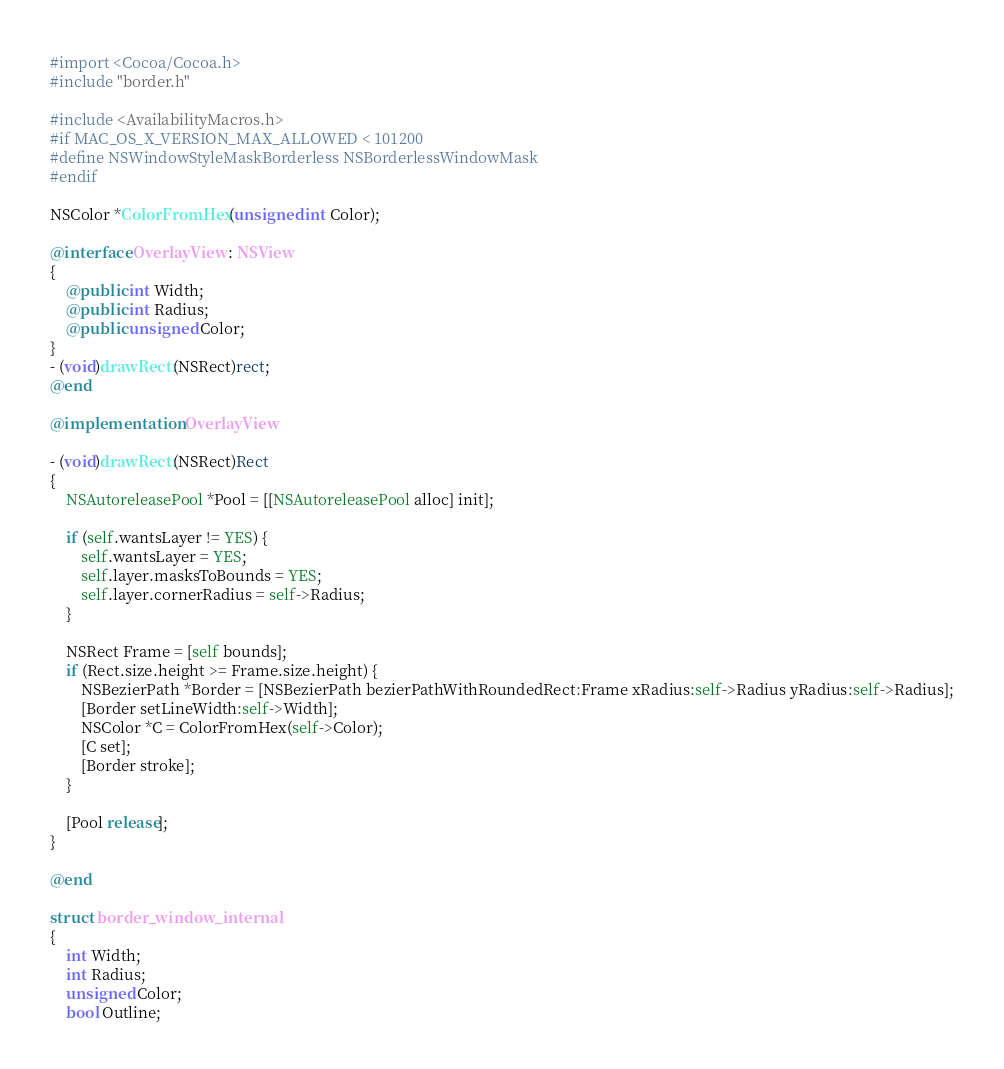Convert code to text. <code><loc_0><loc_0><loc_500><loc_500><_ObjectiveC_>#import <Cocoa/Cocoa.h>
#include "border.h"

#include <AvailabilityMacros.h>
#if MAC_OS_X_VERSION_MAX_ALLOWED < 101200
#define NSWindowStyleMaskBorderless NSBorderlessWindowMask
#endif

NSColor *ColorFromHex(unsigned int Color);

@interface OverlayView : NSView
{
    @public int Width;
    @public int Radius;
    @public unsigned Color;
}
- (void)drawRect:(NSRect)rect;
@end

@implementation OverlayView

- (void)drawRect:(NSRect)Rect
{
    NSAutoreleasePool *Pool = [[NSAutoreleasePool alloc] init];

    if (self.wantsLayer != YES) {
        self.wantsLayer = YES;
        self.layer.masksToBounds = YES;
        self.layer.cornerRadius = self->Radius;
    }

    NSRect Frame = [self bounds];
    if (Rect.size.height >= Frame.size.height) {
        NSBezierPath *Border = [NSBezierPath bezierPathWithRoundedRect:Frame xRadius:self->Radius yRadius:self->Radius];
        [Border setLineWidth:self->Width];
        NSColor *C = ColorFromHex(self->Color);
        [C set];
        [Border stroke];
    }

    [Pool release];
}

@end

struct border_window_internal
{
    int Width;
    int Radius;
    unsigned Color;
    bool Outline;
</code> 